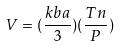Convert formula to latex. <formula><loc_0><loc_0><loc_500><loc_500>V = ( \frac { k b a } { 3 } ) ( \frac { T n } { P } )</formula> 